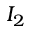Convert formula to latex. <formula><loc_0><loc_0><loc_500><loc_500>I _ { 2 }</formula> 